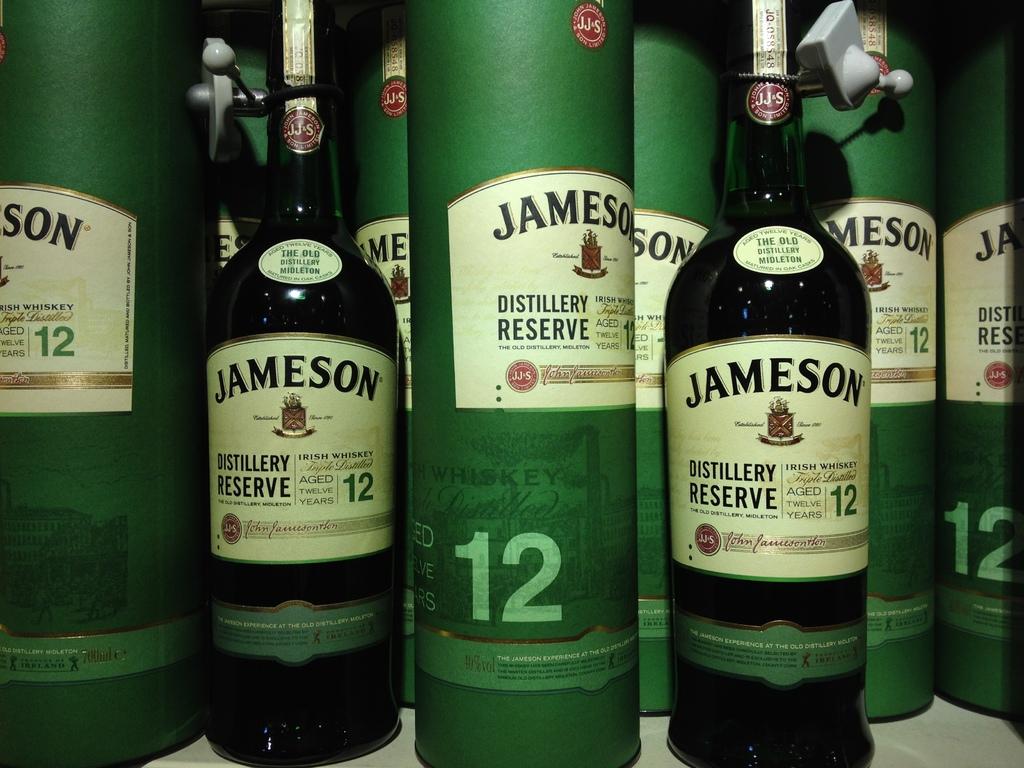What famous brand of reserve liquor is shown?
Provide a short and direct response. Jameson. How long is this whiskey been aged?
Offer a terse response. 12 years. 